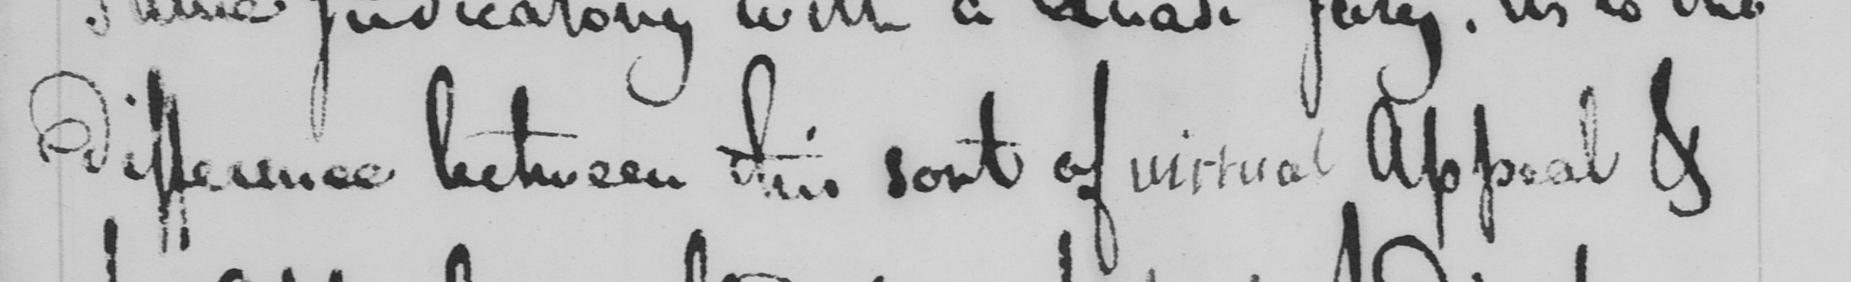What text is written in this handwritten line? difference between this sort of virtual Appeal & 